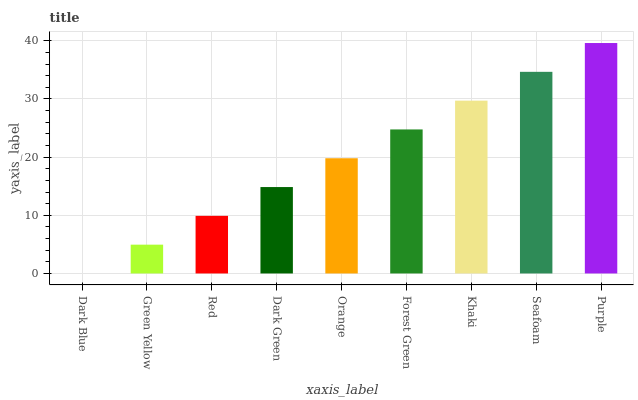Is Green Yellow the minimum?
Answer yes or no. No. Is Green Yellow the maximum?
Answer yes or no. No. Is Green Yellow greater than Dark Blue?
Answer yes or no. Yes. Is Dark Blue less than Green Yellow?
Answer yes or no. Yes. Is Dark Blue greater than Green Yellow?
Answer yes or no. No. Is Green Yellow less than Dark Blue?
Answer yes or no. No. Is Orange the high median?
Answer yes or no. Yes. Is Orange the low median?
Answer yes or no. Yes. Is Dark Green the high median?
Answer yes or no. No. Is Green Yellow the low median?
Answer yes or no. No. 